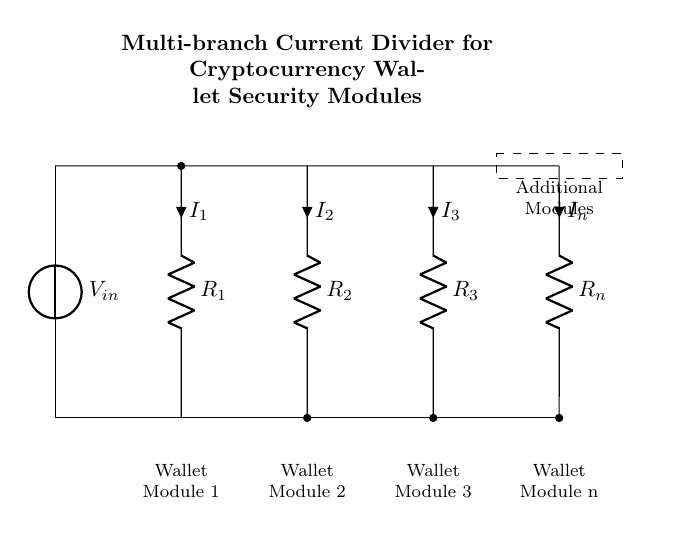What is the input voltage of the circuit? The input voltage is indicated by the voltage source labeled V in the circuit diagram.
Answer: V How many wallet modules are in the circuit? By counting the labeled wallet modules in the diagram, we find there are four wallet modules connected in parallel.
Answer: 4 What is the current flowing through resistor R1? The current through R1 is represented by the label I1 directly above it in the circuit diagram, which indicates it is one of the current outputs in the divider.
Answer: I1 What type of circuit is this? The circuit diagram illustrates a current divider specifically designed for distributing current among multiple branches, which are the wallet security modules.
Answer: Current Divider If R2 and R3 have equal resistance, what can be inferred about I2 and I3? Since R2 and R3 are equal and the voltage across them is the same, by Ohm's Law (current is proportional to the voltage across an equal resistance), I2 and I3 must be equal.
Answer: I2 = I3 What does the dashed box represent in the diagram? The dashed box signifies additional modules that can be incorporated into the existing current divider configuration, indicating expandability or modularity in the circuit design.
Answer: Additional Modules 